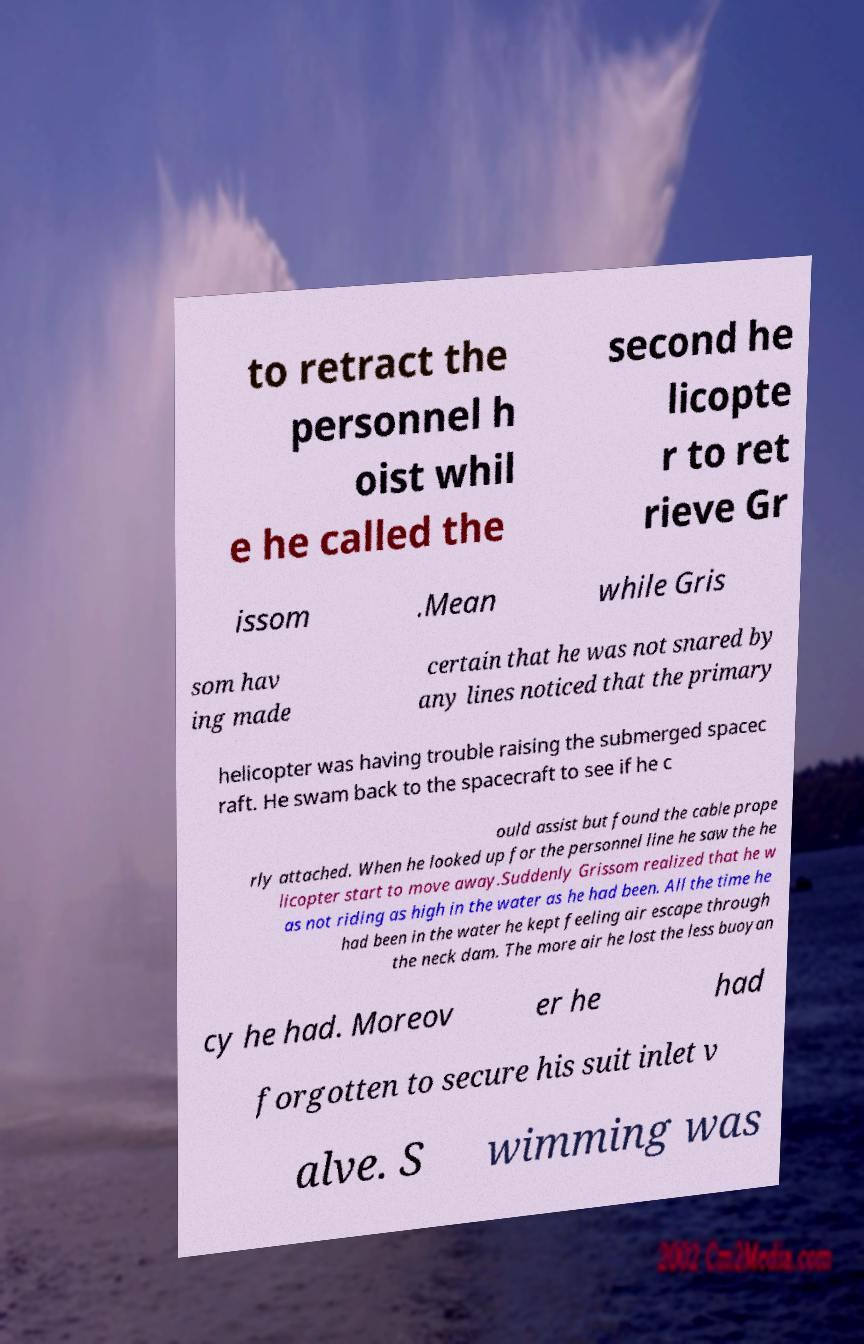For documentation purposes, I need the text within this image transcribed. Could you provide that? to retract the personnel h oist whil e he called the second he licopte r to ret rieve Gr issom .Mean while Gris som hav ing made certain that he was not snared by any lines noticed that the primary helicopter was having trouble raising the submerged spacec raft. He swam back to the spacecraft to see if he c ould assist but found the cable prope rly attached. When he looked up for the personnel line he saw the he licopter start to move away.Suddenly Grissom realized that he w as not riding as high in the water as he had been. All the time he had been in the water he kept feeling air escape through the neck dam. The more air he lost the less buoyan cy he had. Moreov er he had forgotten to secure his suit inlet v alve. S wimming was 